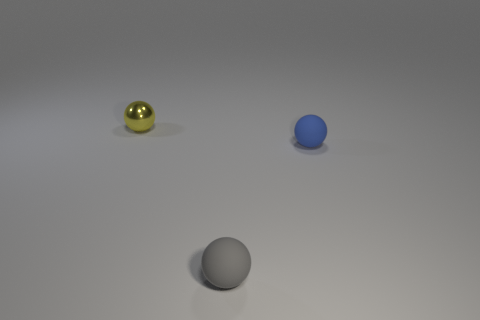Subtract all matte spheres. How many spheres are left? 1 Subtract all blue balls. How many balls are left? 2 Add 3 blue rubber things. How many objects exist? 6 Subtract 1 spheres. How many spheres are left? 2 Add 2 small rubber things. How many small rubber things exist? 4 Subtract 0 brown spheres. How many objects are left? 3 Subtract all yellow balls. Subtract all red blocks. How many balls are left? 2 Subtract all tiny shiny balls. Subtract all small gray matte things. How many objects are left? 1 Add 3 blue spheres. How many blue spheres are left? 4 